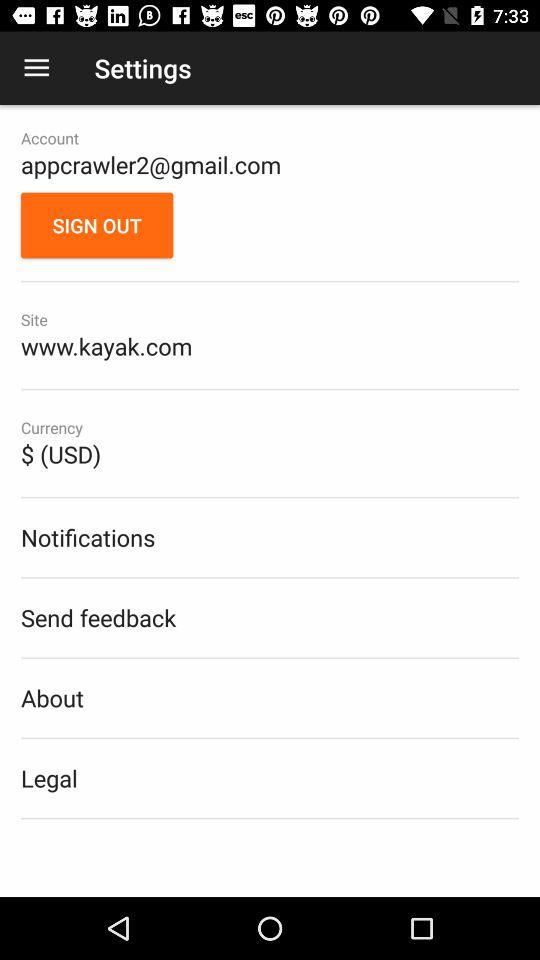What currency has been selected? The selected currency is $. 